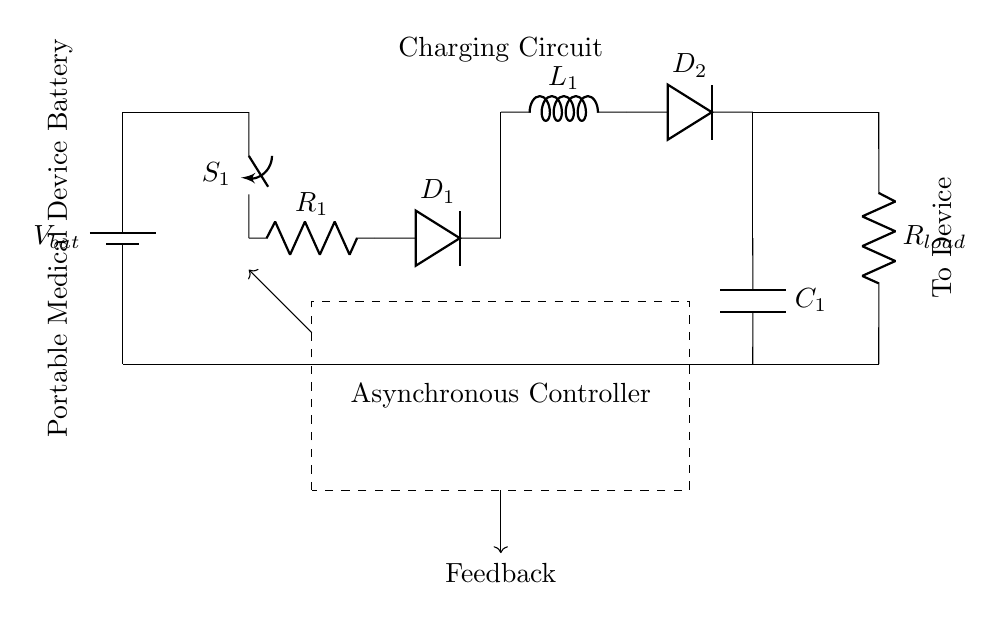What is the primary function of the battery in this circuit? The battery provides the initial power, represented by V bat, to the charging circuit, enabling it to function.
Answer: power supply What components are used for charging in this circuit? The charging components include a closing switch, resistor, and two diodes that allow current to flow towards the load and regulate the charging process.
Answer: switch, resistor, diodes What does the feedback signal control in this circuit? The feedback signal is sent to the asynchronous controller, allowing it to adjust the circuit operation, such as the opening or closing of switches based on the battery's state.
Answer: asynchronous controller Which component is responsible for voltage regulation in the circuit? The voltage regulator is represented by the cute inductor and adjacent diode, ensuring that the output voltage remains stable and within range for the load.
Answer: inductor How many resistors are present in this circuit? There are two resistors included: R1 for the charging circuit and Rload for the output connection to the device.
Answer: two What type of circuit governance does this circuit depict? This circuit employs an asynchronous control mechanism, meaning that control actions are not synchronized to a clock signal but occur based on the feedback.
Answer: asynchronous control 